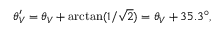<formula> <loc_0><loc_0><loc_500><loc_500>\theta _ { V } ^ { \prime } = \theta _ { V } + \arctan ( 1 / \sqrt { 2 } ) = \theta _ { V } + 3 5 . 3 ^ { \circ } ,</formula> 